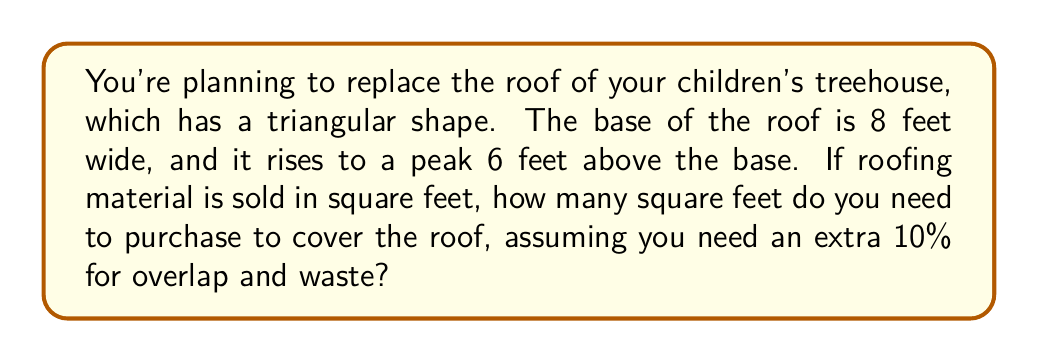Give your solution to this math problem. Let's approach this step-by-step:

1) First, we need to find the slant height of the roof. We can do this using the Pythagorean theorem.

2) The base of the roof forms a right triangle. We know:
   - Half of the base width is 4 feet (8 ÷ 2)
   - The height is 6 feet

3) Let's call the slant height $s$. Using the Pythagorean theorem:

   $$s^2 = 4^2 + 6^2$$
   $$s^2 = 16 + 36 = 52$$
   $$s = \sqrt{52} \approx 7.21 \text{ feet}$$

4) Now we can calculate the area of the triangular roof:

   $$\text{Area} = \frac{1}{2} \times \text{base} \times \text{slant height}$$
   $$\text{Area} = \frac{1}{2} \times 8 \times 7.21 \approx 28.84 \text{ square feet}$$

5) We need to add 10% for overlap and waste:

   $$\text{Total area needed} = 28.84 \times 1.1 \approx 31.72 \text{ square feet}$$

6) Rounding up to the nearest square foot (as we can't buy partial square feet):

   $$\text{Final amount needed} = 32 \text{ square feet}$$

[asy]
import geometry;

size(200);

pair A = (0,0), B = (8,0), C = (4,6);
draw(A--B--C--A);
draw(B--C,dashed);

label("8 ft", (4,0), S);
label("6 ft", (4,0), E);
label("s", (6,3), SE);

dot("A", A, SW);
dot("B", B, SE);
dot("C", C, N);
[/asy]
Answer: 32 square feet 